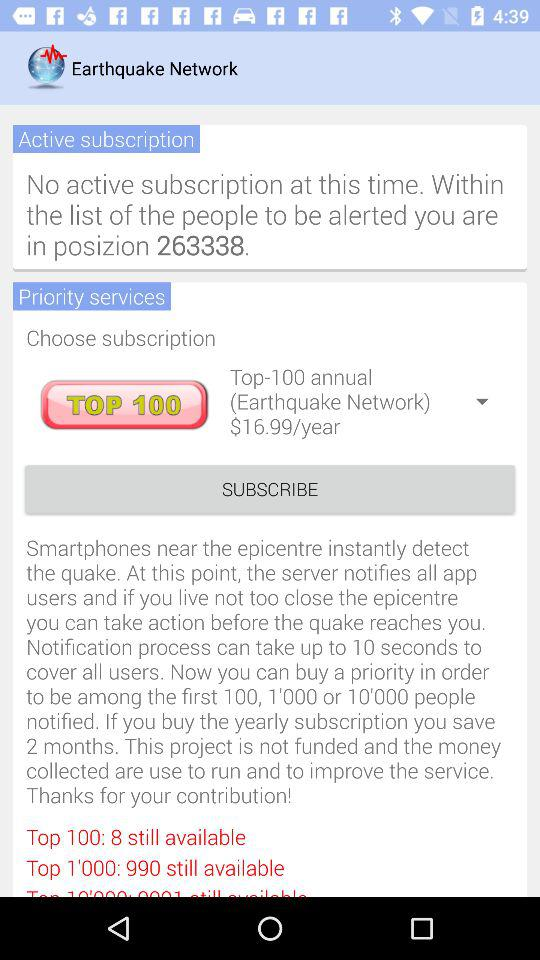What is the application name? The application name is "Earthquake Network". 